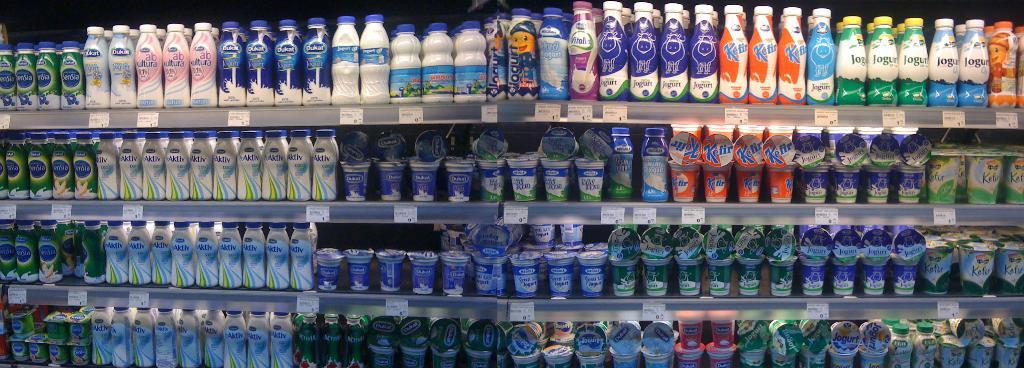What is the main object in the image? There is a rack in the image. What is placed on the rack? There are many bottles on the rack. Are there any other items on the rack besides bottles? Yes, there are cups on the rack. Where are the bottles located on the rack? The bottles are on the left side of the rack. Where are the cups located on the rack? The cups are on the bottom side of the rack. What type of gun is hidden behind the bottles on the rack? There is no gun present in the image; it only features a rack with bottles and cups. 